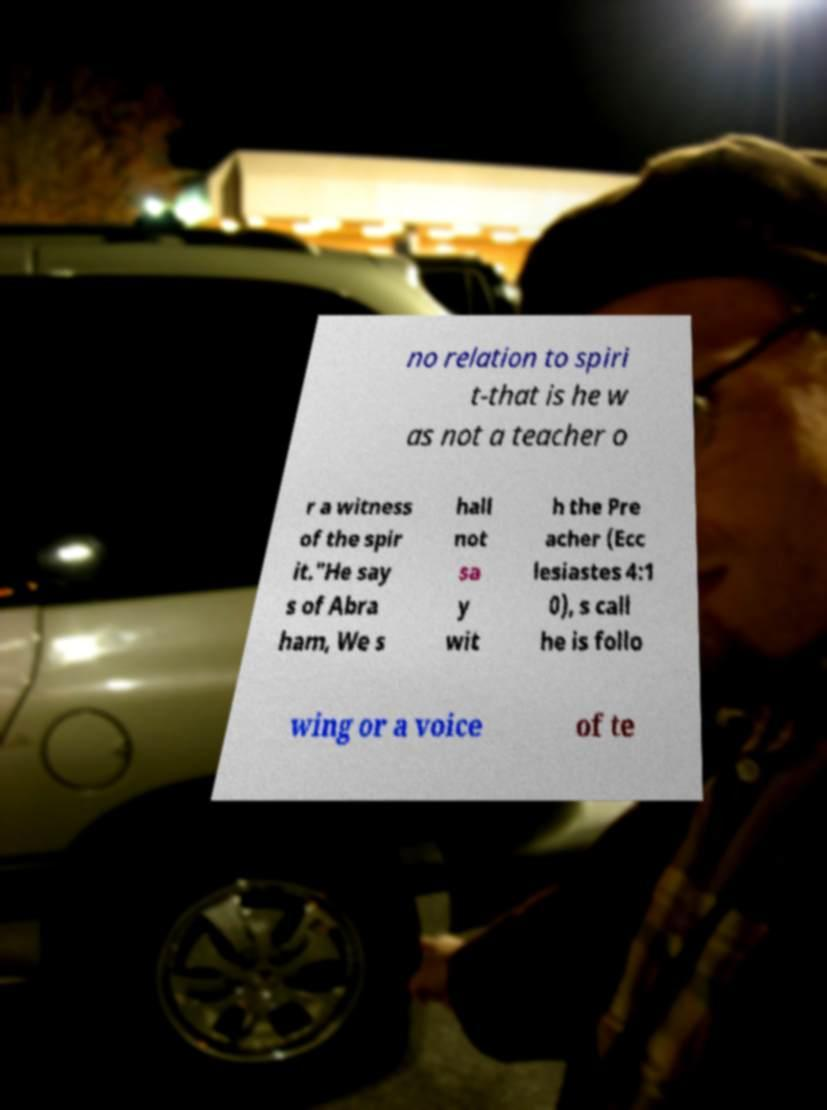For documentation purposes, I need the text within this image transcribed. Could you provide that? no relation to spiri t-that is he w as not a teacher o r a witness of the spir it."He say s of Abra ham, We s hall not sa y wit h the Pre acher (Ecc lesiastes 4:1 0), s call he is follo wing or a voice of te 